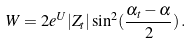<formula> <loc_0><loc_0><loc_500><loc_500>W = 2 e ^ { U } | Z _ { t } | \sin ^ { 2 } ( \frac { \alpha _ { t } - \alpha } { 2 } ) \, .</formula> 